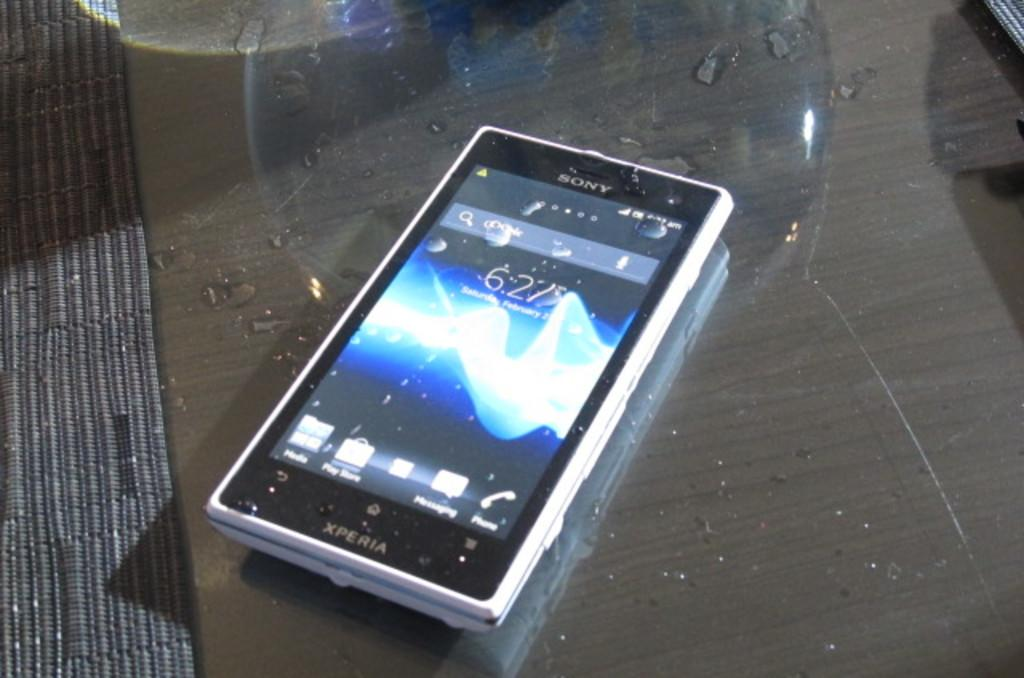<image>
Create a compact narrative representing the image presented. Sony cellphone showing the time at 6:27 on top of a table. 